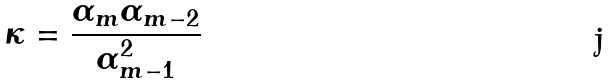Convert formula to latex. <formula><loc_0><loc_0><loc_500><loc_500>\kappa = \frac { \alpha _ { m } \alpha _ { m - 2 } } { \alpha _ { m - 1 } ^ { 2 } }</formula> 